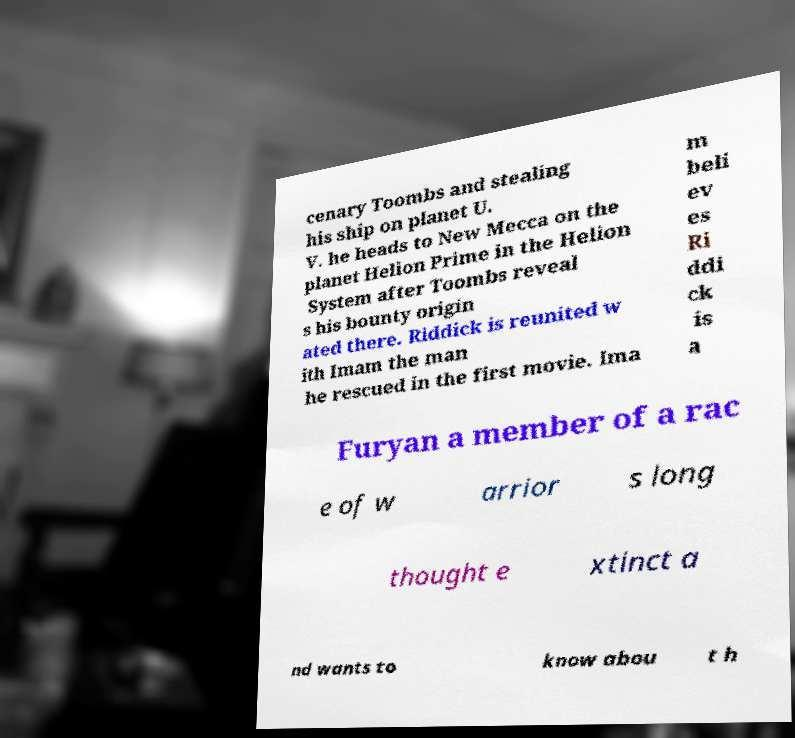Please read and relay the text visible in this image. What does it say? cenary Toombs and stealing his ship on planet U. V. he heads to New Mecca on the planet Helion Prime in the Helion System after Toombs reveal s his bounty origin ated there. Riddick is reunited w ith Imam the man he rescued in the first movie. Ima m beli ev es Ri ddi ck is a Furyan a member of a rac e of w arrior s long thought e xtinct a nd wants to know abou t h 